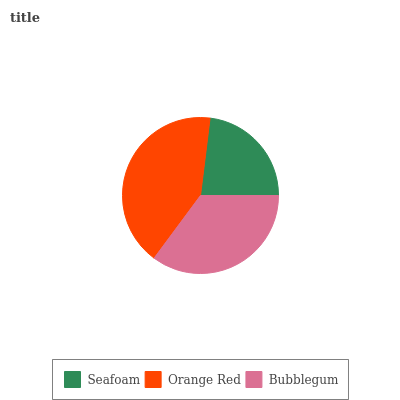Is Seafoam the minimum?
Answer yes or no. Yes. Is Orange Red the maximum?
Answer yes or no. Yes. Is Bubblegum the minimum?
Answer yes or no. No. Is Bubblegum the maximum?
Answer yes or no. No. Is Orange Red greater than Bubblegum?
Answer yes or no. Yes. Is Bubblegum less than Orange Red?
Answer yes or no. Yes. Is Bubblegum greater than Orange Red?
Answer yes or no. No. Is Orange Red less than Bubblegum?
Answer yes or no. No. Is Bubblegum the high median?
Answer yes or no. Yes. Is Bubblegum the low median?
Answer yes or no. Yes. Is Seafoam the high median?
Answer yes or no. No. Is Orange Red the low median?
Answer yes or no. No. 